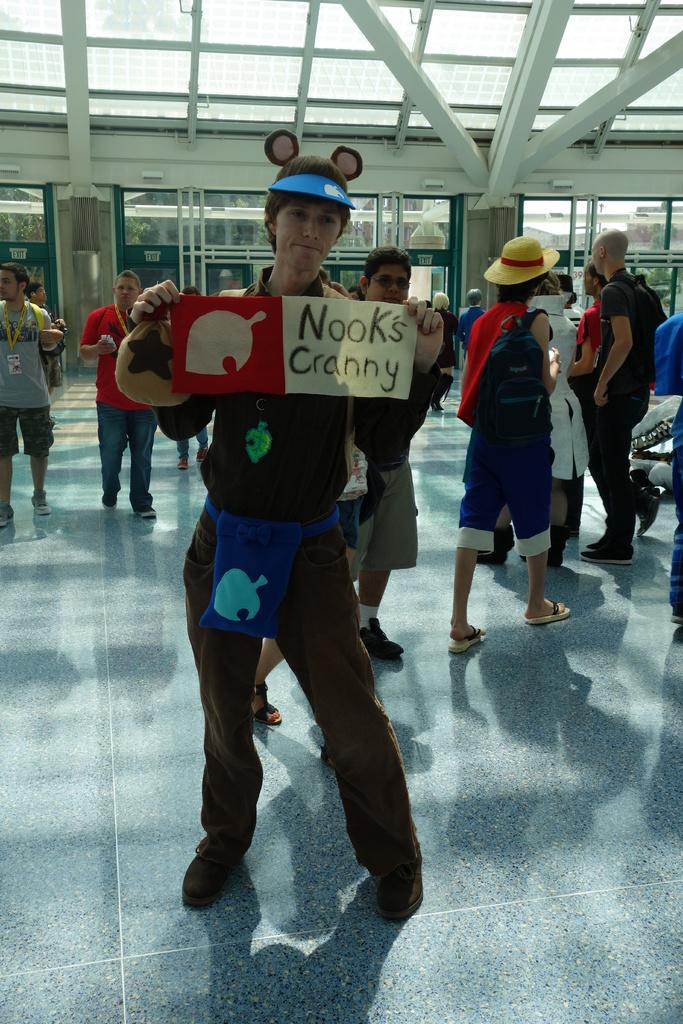What is the main subject of the image? There is a man standing on the ground in the image. What can be seen happening in the background of the image? There is a group of persons walking in the background of the image. What object is present in the image that is made of glass? There is a window glass in the image. What part of a building can be seen above the man in the image? The roof is visible above in the image. What type of lamp is hanging from the roof in the image? There is no lamp present in the image; only the man, the group of persons, the window glass, and the roof are visible. 